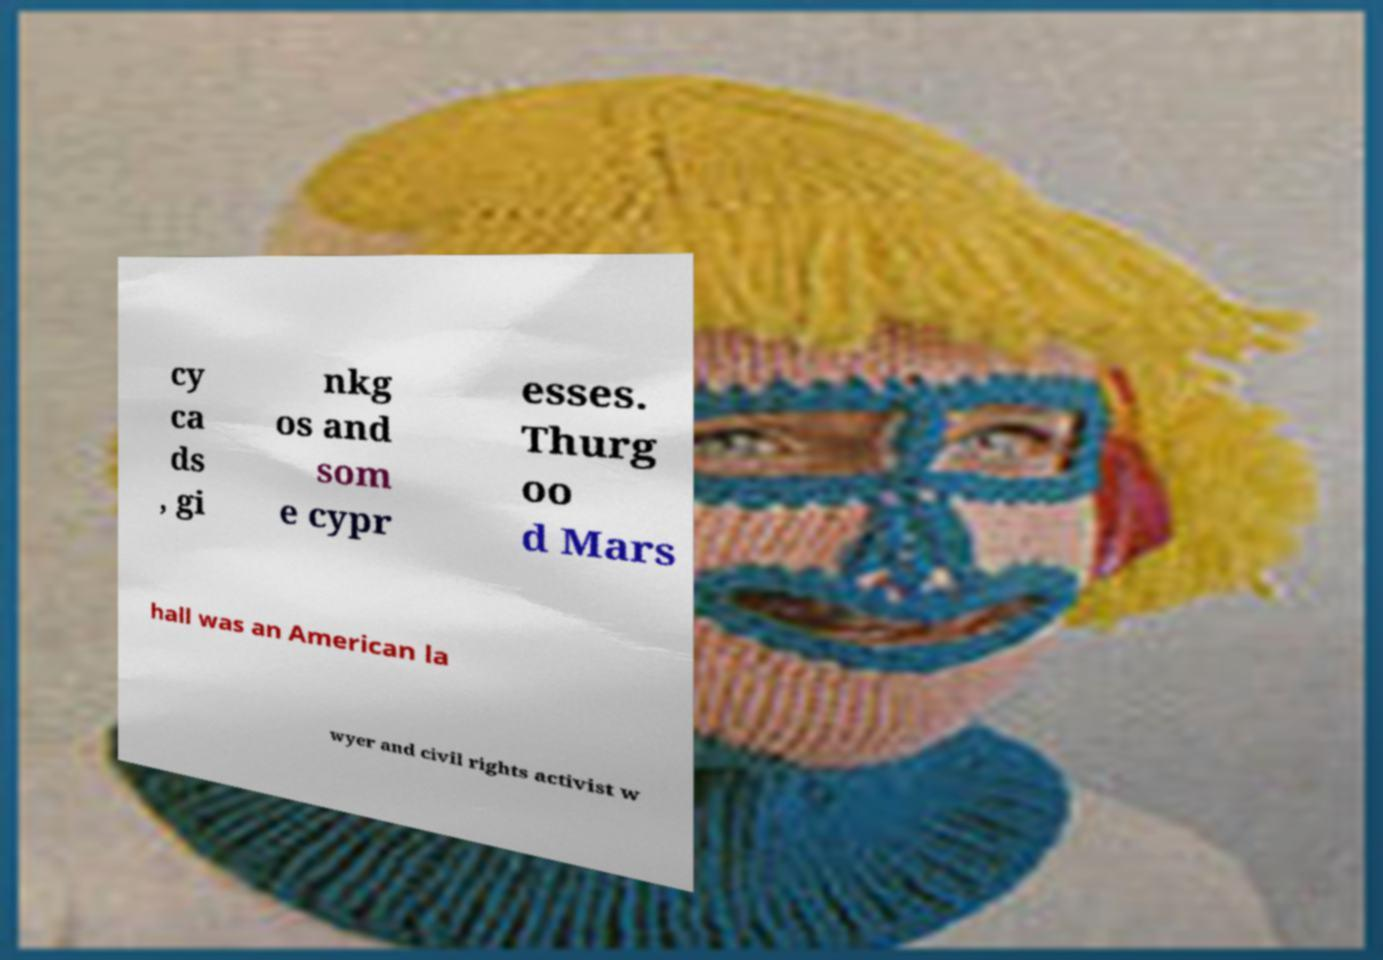What messages or text are displayed in this image? I need them in a readable, typed format. cy ca ds , gi nkg os and som e cypr esses. Thurg oo d Mars hall was an American la wyer and civil rights activist w 